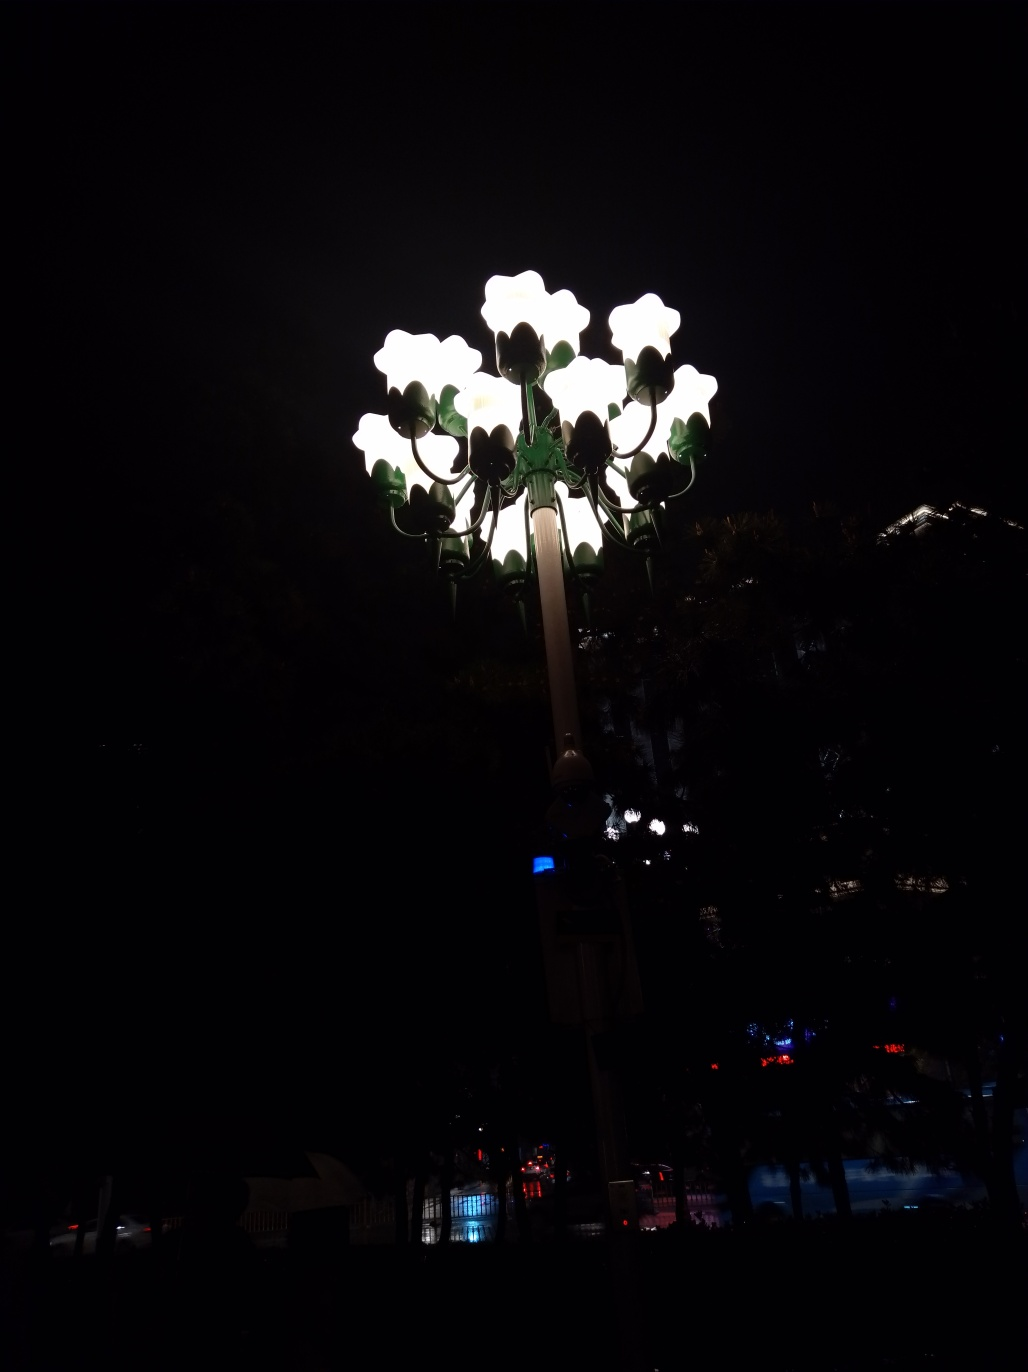Can you suggest the mood or feeling this photo evokes? The photo's focus on a cluster of bright lamps glowing against a pitch-black background can evoke a sense of isolation or solitude. It might also suggest a beacon of warmth and brightness in the darkness, offering a feeling of safety or a welcoming glow in the night. 